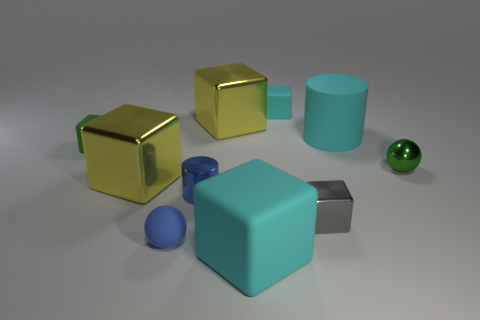Are there any small matte things that have the same color as the large matte cylinder?
Keep it short and to the point. Yes. What number of small things are either blue matte objects or purple matte balls?
Keep it short and to the point. 1. What number of metallic cubes are there?
Provide a succinct answer. 3. There is a blue thing behind the tiny gray metallic cube; what is its material?
Offer a terse response. Metal. Are there any gray objects in front of the small gray metal block?
Your response must be concise. No. Do the blue cylinder and the rubber sphere have the same size?
Provide a short and direct response. Yes. What number of small blue spheres have the same material as the tiny cyan object?
Offer a very short reply. 1. There is a cyan cube that is behind the large yellow shiny cube on the right side of the matte ball; what size is it?
Your response must be concise. Small. The block that is behind the big cylinder and on the left side of the small cyan cube is what color?
Your answer should be very brief. Yellow. Is the small blue matte object the same shape as the tiny cyan rubber thing?
Provide a succinct answer. No. 